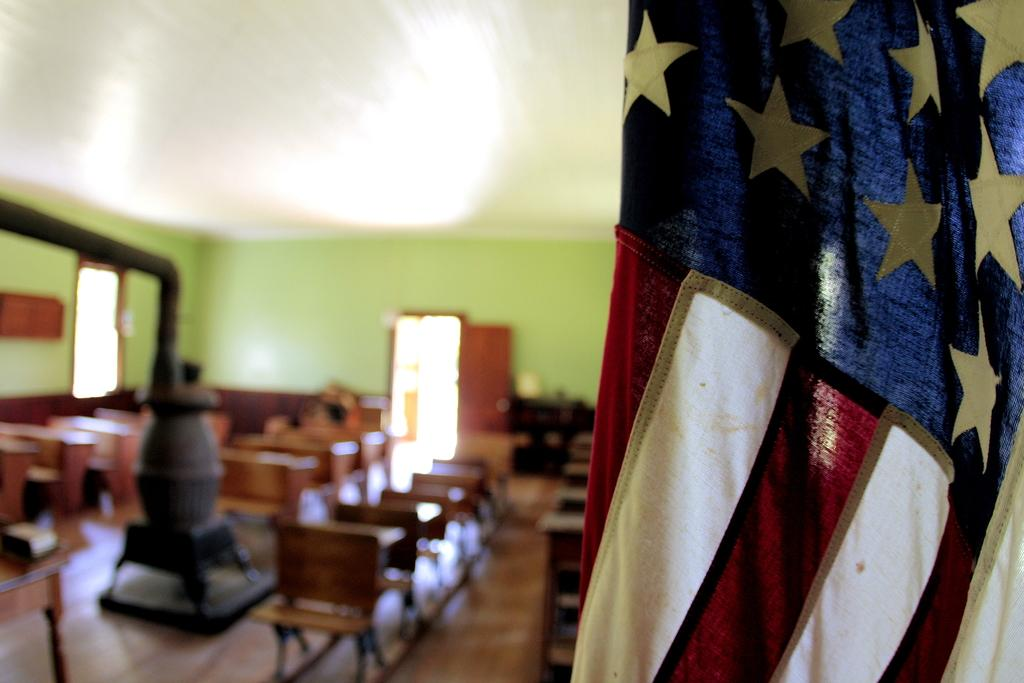What is the setting of the image? The image shows the inside view of a room. What type of furniture is present in the room? There are benches in the room. What color is the wall in the room? The wall is green in color. How can one enter or exit the room? There is a door in the room. What decorative item can be seen in the room? There is a flag in the room. Can you see any animals from the garden in the image? There is no garden or animals present in the image; it shows the inside view of a room with benches, a green wall, a door, and a flag. 